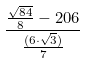Convert formula to latex. <formula><loc_0><loc_0><loc_500><loc_500>\frac { \frac { \sqrt { 8 4 } } { 8 } - 2 0 6 } { \frac { ( 6 \cdot \sqrt { 3 } ) } { 7 } }</formula> 